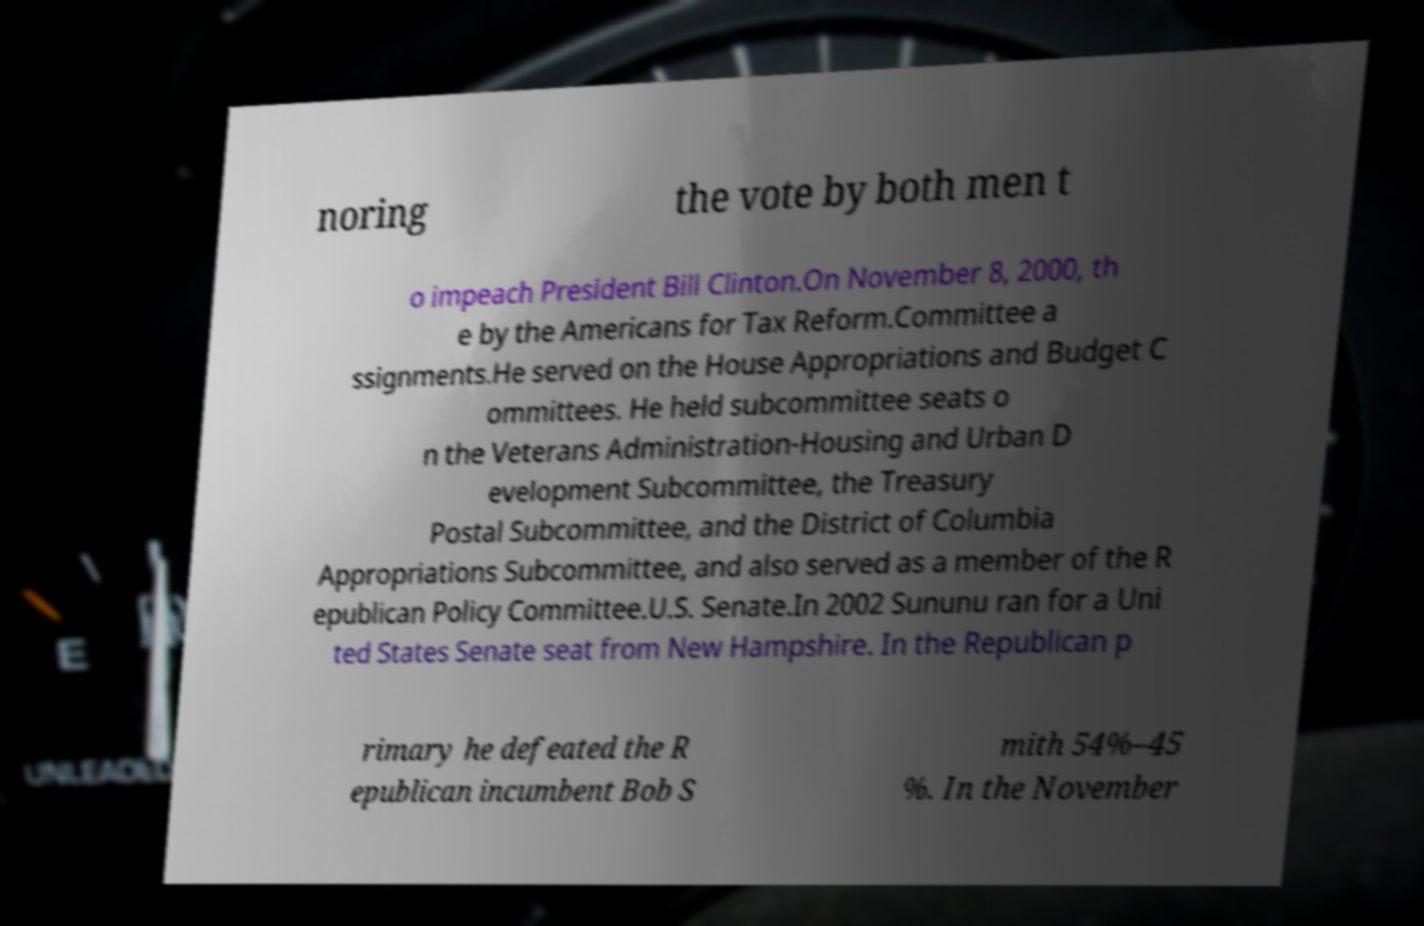I need the written content from this picture converted into text. Can you do that? noring the vote by both men t o impeach President Bill Clinton.On November 8, 2000, th e by the Americans for Tax Reform.Committee a ssignments.He served on the House Appropriations and Budget C ommittees. He held subcommittee seats o n the Veterans Administration-Housing and Urban D evelopment Subcommittee, the Treasury Postal Subcommittee, and the District of Columbia Appropriations Subcommittee, and also served as a member of the R epublican Policy Committee.U.S. Senate.In 2002 Sununu ran for a Uni ted States Senate seat from New Hampshire. In the Republican p rimary he defeated the R epublican incumbent Bob S mith 54%–45 %. In the November 